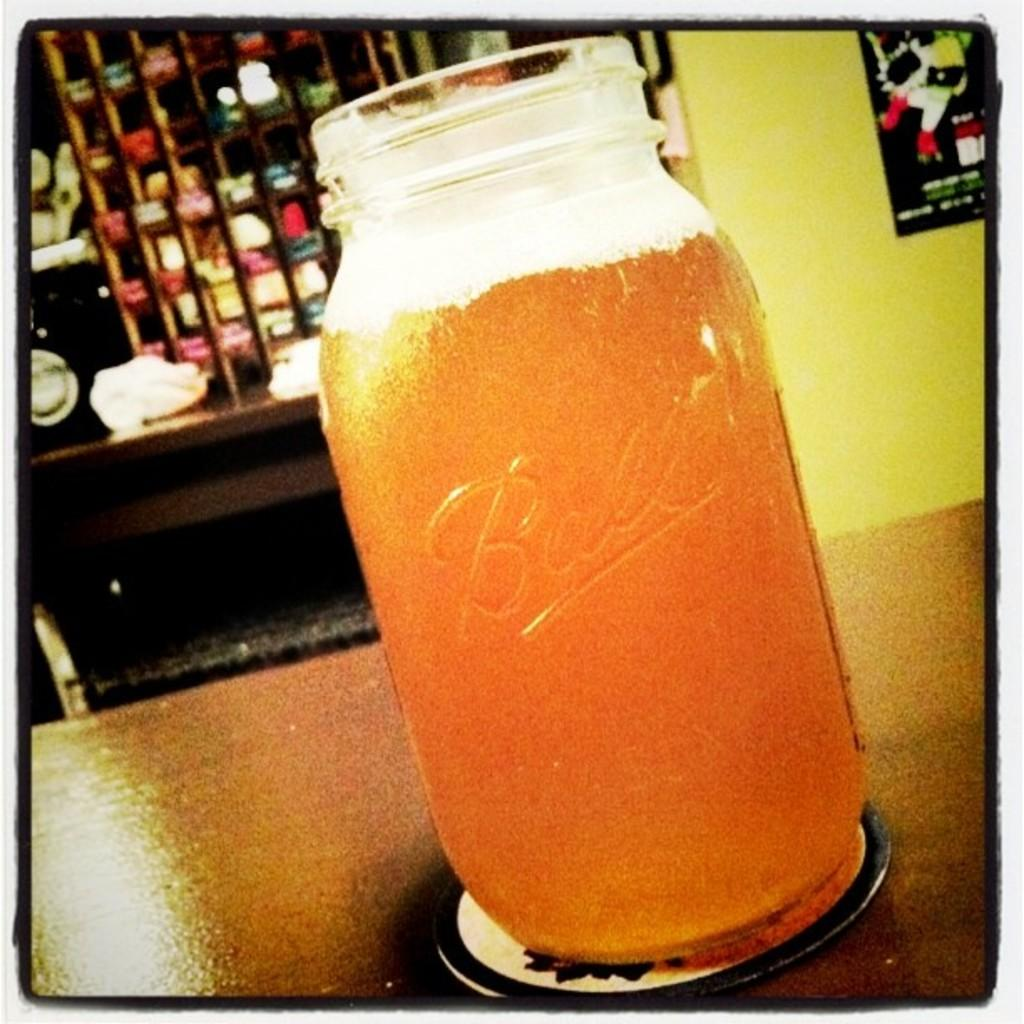What is contained in the bottle that is visible in the image? There is a drink in the bottle that is visible in the image. What is located on the table in the image? There is an object on the table in the image. What can be seen on the wall in the background of the image? There is a poster on the wall in the background of the image. What else is visible in the background of the image? There are other objects visible in the background of the image. Is there a ball being used for a game of volleyball in the image? There is no ball or game of volleyball present in the image. Is there a laborer working in the background of the image? There is no laborer or indication of work being done in the image. 